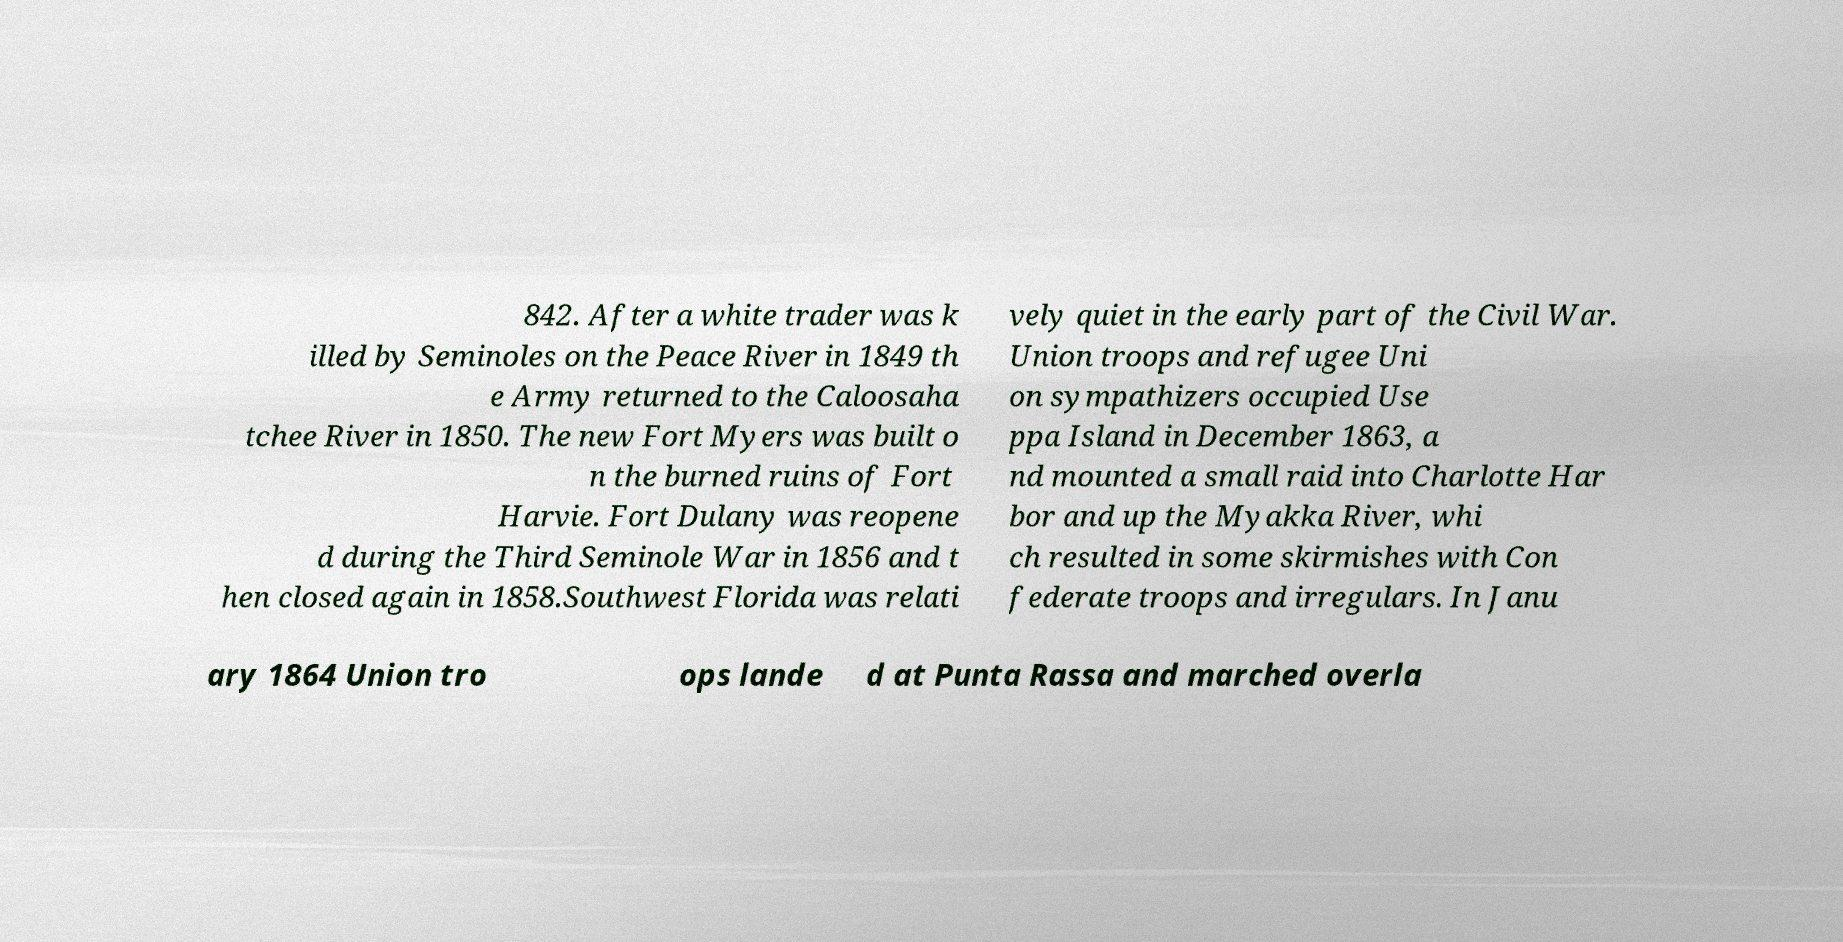What messages or text are displayed in this image? I need them in a readable, typed format. 842. After a white trader was k illed by Seminoles on the Peace River in 1849 th e Army returned to the Caloosaha tchee River in 1850. The new Fort Myers was built o n the burned ruins of Fort Harvie. Fort Dulany was reopene d during the Third Seminole War in 1856 and t hen closed again in 1858.Southwest Florida was relati vely quiet in the early part of the Civil War. Union troops and refugee Uni on sympathizers occupied Use ppa Island in December 1863, a nd mounted a small raid into Charlotte Har bor and up the Myakka River, whi ch resulted in some skirmishes with Con federate troops and irregulars. In Janu ary 1864 Union tro ops lande d at Punta Rassa and marched overla 